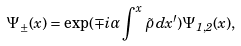<formula> <loc_0><loc_0><loc_500><loc_500>\Psi _ { \pm } ( x ) = \exp ( \mp i \alpha \int ^ { x } \tilde { \rho } \, d x ^ { \prime } ) \Psi _ { 1 , 2 } ( x ) ,</formula> 